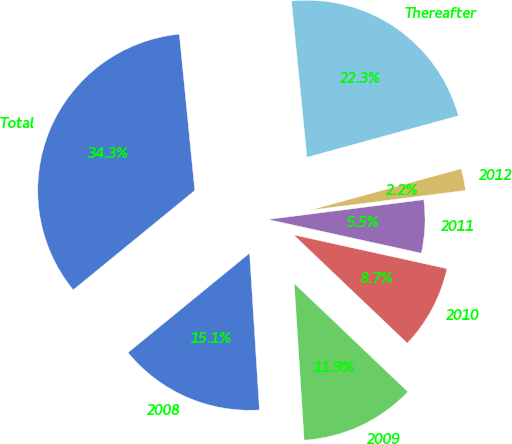Convert chart. <chart><loc_0><loc_0><loc_500><loc_500><pie_chart><fcel>2008<fcel>2009<fcel>2010<fcel>2011<fcel>2012<fcel>Thereafter<fcel>Total<nl><fcel>15.09%<fcel>11.88%<fcel>8.67%<fcel>5.46%<fcel>2.25%<fcel>22.31%<fcel>34.34%<nl></chart> 